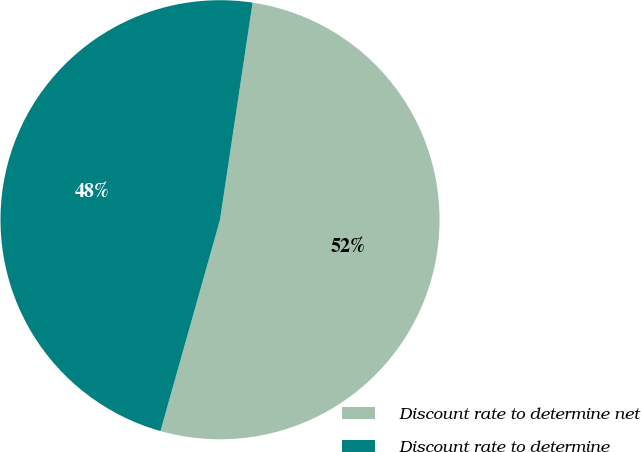Convert chart to OTSL. <chart><loc_0><loc_0><loc_500><loc_500><pie_chart><fcel>Discount rate to determine net<fcel>Discount rate to determine<nl><fcel>52.0%<fcel>48.0%<nl></chart> 